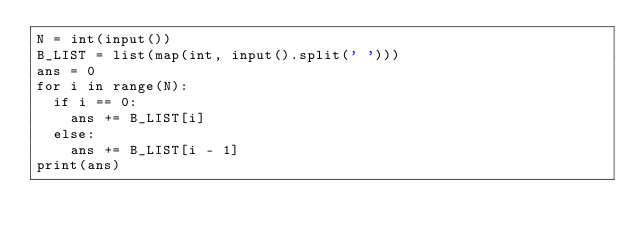<code> <loc_0><loc_0><loc_500><loc_500><_Python_>N = int(input())
B_LIST = list(map(int, input().split(' ')))
ans = 0
for i in range(N):
  if i == 0:
    ans += B_LIST[i]
  else:
    ans += B_LIST[i - 1]
print(ans)</code> 